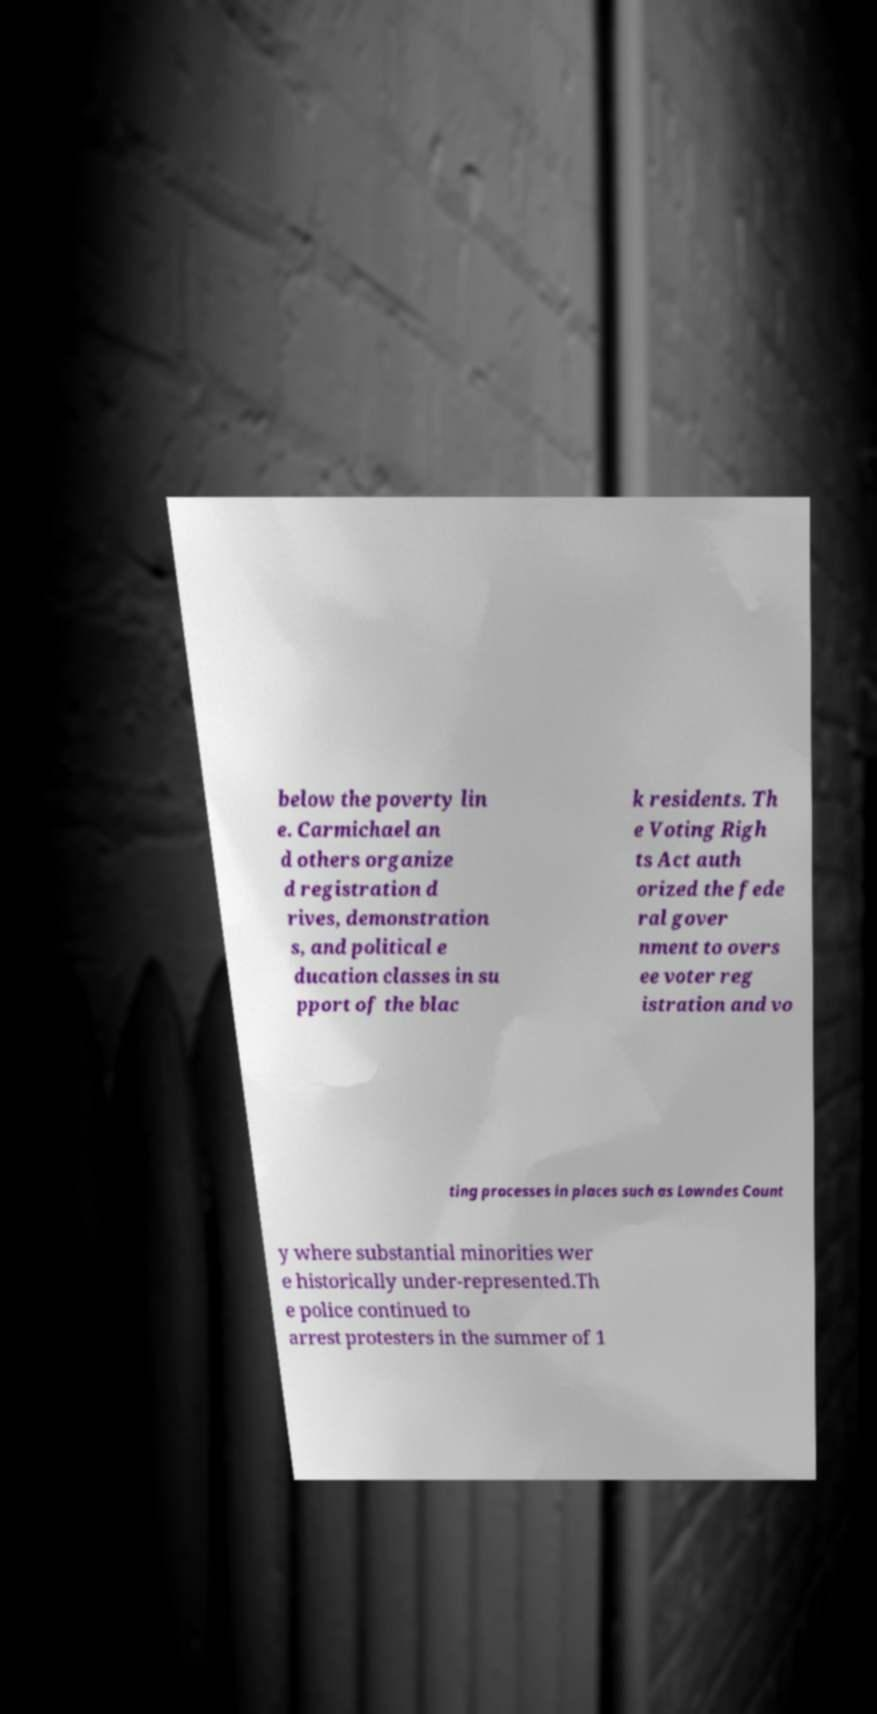There's text embedded in this image that I need extracted. Can you transcribe it verbatim? below the poverty lin e. Carmichael an d others organize d registration d rives, demonstration s, and political e ducation classes in su pport of the blac k residents. Th e Voting Righ ts Act auth orized the fede ral gover nment to overs ee voter reg istration and vo ting processes in places such as Lowndes Count y where substantial minorities wer e historically under-represented.Th e police continued to arrest protesters in the summer of 1 